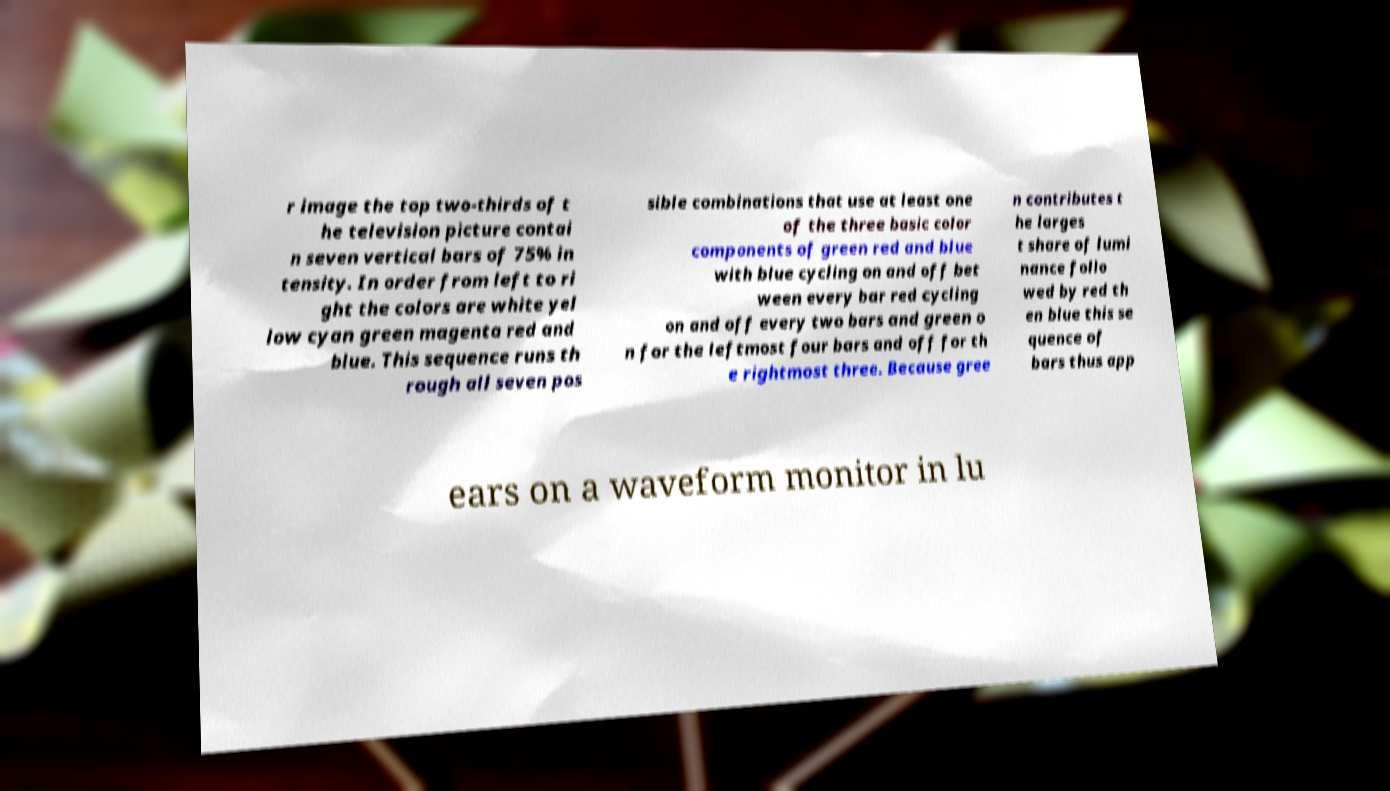I need the written content from this picture converted into text. Can you do that? r image the top two-thirds of t he television picture contai n seven vertical bars of 75% in tensity. In order from left to ri ght the colors are white yel low cyan green magenta red and blue. This sequence runs th rough all seven pos sible combinations that use at least one of the three basic color components of green red and blue with blue cycling on and off bet ween every bar red cycling on and off every two bars and green o n for the leftmost four bars and off for th e rightmost three. Because gree n contributes t he larges t share of lumi nance follo wed by red th en blue this se quence of bars thus app ears on a waveform monitor in lu 